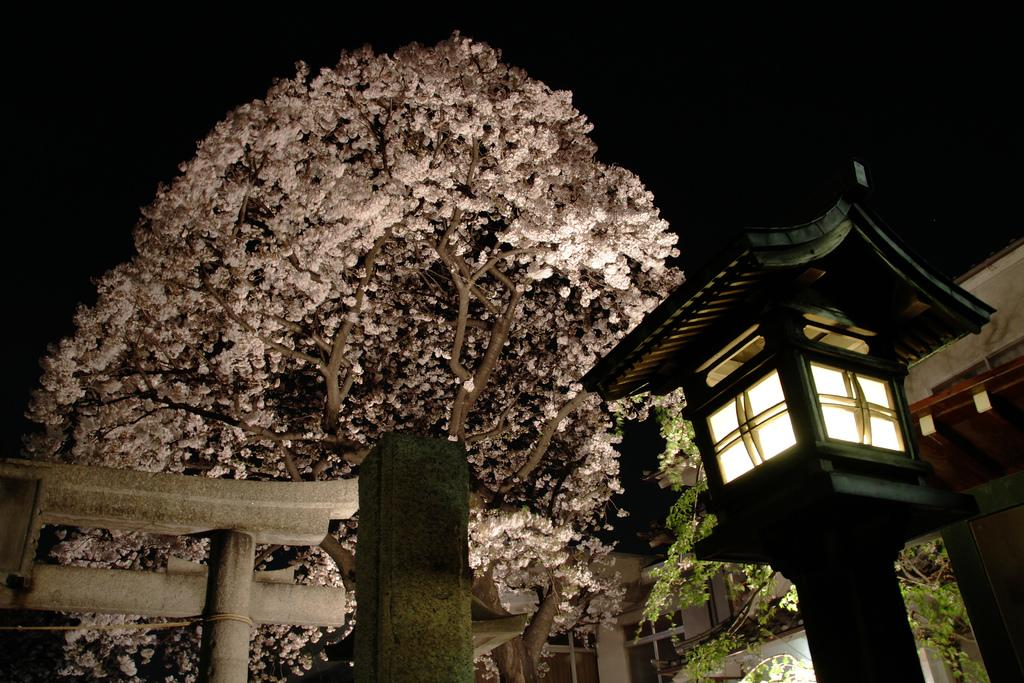What type of natural element is present in the image? There is a tree in the image. What artificial element can be seen on the right side of the image? There is a street light on the right side of the image. What type of structure is present in the image? There is a gate in the image. What type of man-made structure is visible in the background? There is a building in the image. What type of barrier can be seen in the bottom left of the image? There is a wooden railing in the bottom left of the image. How would you describe the lighting at the top of the image? The top of the image appears to be dark. What type of skin condition can be seen on the tree in the image? There is no skin condition present on the tree in the image; it is a natural element with bark. What type of print is visible on the street light in the image? There is no print visible on the street light in the image; it is an artificial element with a standard design. 